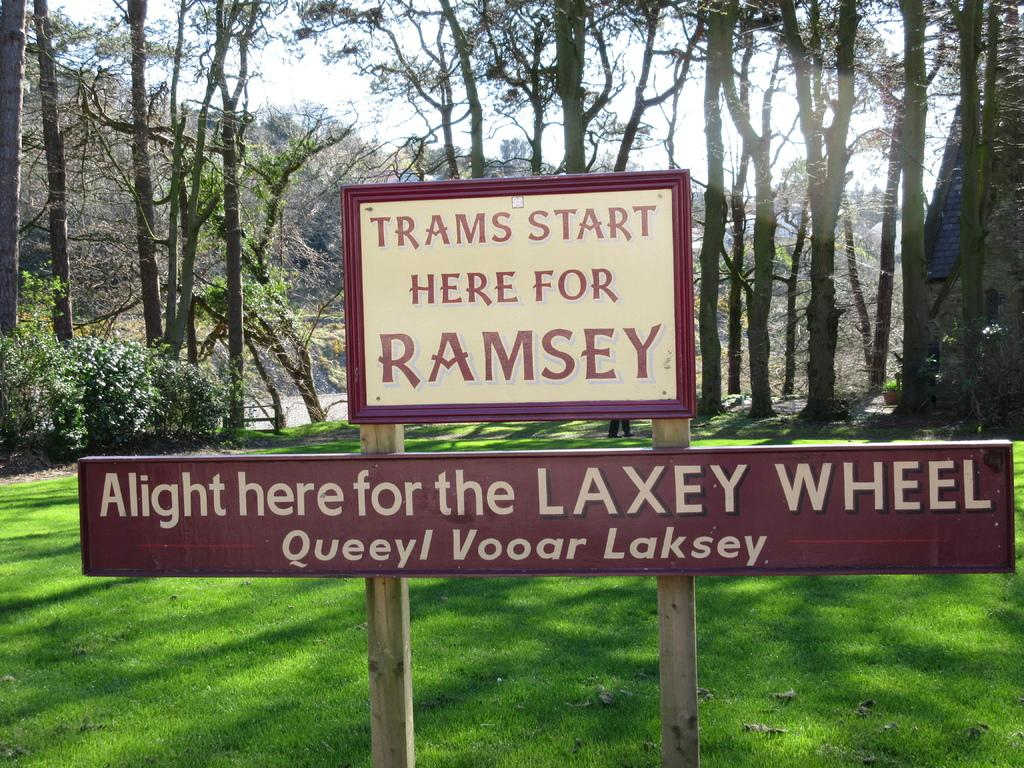What type of vegetation can be seen in the image? There are trees in the image. What is written on the board in the image? There is a board with writing in the image. What type of ground surface is visible in the image? There is grass visible in the image. What can be seen in the background of the image? The sky is visible in the background of the image. What type of creature is shown interacting with the board in the image? There is no creature shown interacting with the board in the image; only the board with writing is present. How much payment is required to access the view in the image? There is no mention of payment or accessing a view in the image; it simply shows trees, a board with writing, grass, and the sky. 